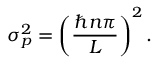<formula> <loc_0><loc_0><loc_500><loc_500>\sigma _ { p } ^ { 2 } = \left ( { \frac { \hbar { n } \pi } { L } } \right ) ^ { 2 } .</formula> 